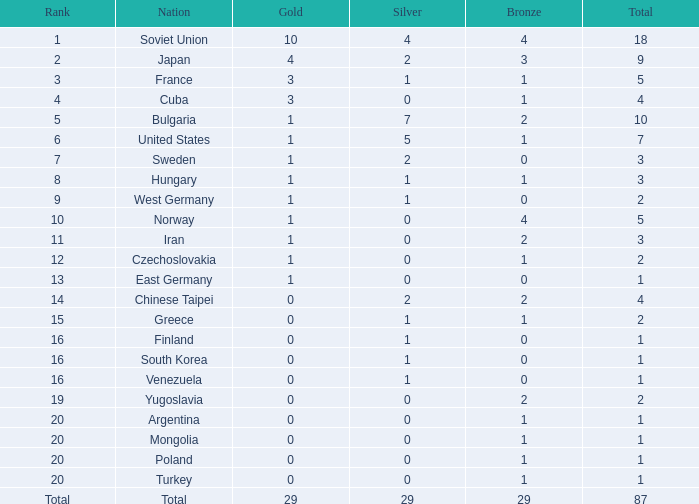Parse the table in full. {'header': ['Rank', 'Nation', 'Gold', 'Silver', 'Bronze', 'Total'], 'rows': [['1', 'Soviet Union', '10', '4', '4', '18'], ['2', 'Japan', '4', '2', '3', '9'], ['3', 'France', '3', '1', '1', '5'], ['4', 'Cuba', '3', '0', '1', '4'], ['5', 'Bulgaria', '1', '7', '2', '10'], ['6', 'United States', '1', '5', '1', '7'], ['7', 'Sweden', '1', '2', '0', '3'], ['8', 'Hungary', '1', '1', '1', '3'], ['9', 'West Germany', '1', '1', '0', '2'], ['10', 'Norway', '1', '0', '4', '5'], ['11', 'Iran', '1', '0', '2', '3'], ['12', 'Czechoslovakia', '1', '0', '1', '2'], ['13', 'East Germany', '1', '0', '0', '1'], ['14', 'Chinese Taipei', '0', '2', '2', '4'], ['15', 'Greece', '0', '1', '1', '2'], ['16', 'Finland', '0', '1', '0', '1'], ['16', 'South Korea', '0', '1', '0', '1'], ['16', 'Venezuela', '0', '1', '0', '1'], ['19', 'Yugoslavia', '0', '0', '2', '2'], ['20', 'Argentina', '0', '0', '1', '1'], ['20', 'Mongolia', '0', '0', '1', '1'], ['20', 'Poland', '0', '0', '1', '1'], ['20', 'Turkey', '0', '0', '1', '1'], ['Total', 'Total', '29', '29', '29', '87']]} Which rank has 1 silver medal and more than 1 gold medal? 3.0. 